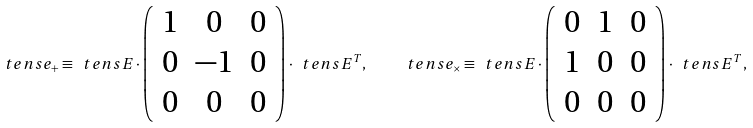Convert formula to latex. <formula><loc_0><loc_0><loc_500><loc_500>\ t e n s { e } _ { + } \equiv \ t e n s { E } \cdot \left ( \begin{array} { c c c } 1 & 0 & 0 \\ 0 & - 1 & 0 \\ 0 & 0 & 0 \end{array} \right ) \cdot \ t e n s { E } ^ { T } , \quad \ t e n s { e } _ { \times } \equiv \ t e n s { E } \cdot \left ( \begin{array} { c c c } 0 & 1 & 0 \\ 1 & 0 & 0 \\ 0 & 0 & 0 \end{array} \right ) \cdot \ t e n s { E } ^ { T } ,</formula> 